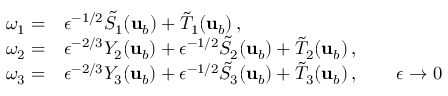<formula> <loc_0><loc_0><loc_500><loc_500>\begin{array} { r l } { \omega _ { 1 } = } & { \epsilon ^ { - 1 / 2 } \tilde { S } _ { 1 } ( { u } _ { b } ) + \tilde { T } _ { 1 } ( { u } _ { b } ) \, , } \\ { \omega _ { 2 } = } & { \epsilon ^ { - 2 / 3 } Y _ { 2 } ( { u } _ { b } ) + \epsilon ^ { - 1 / 2 } \tilde { S } _ { 2 } ( { u } _ { b } ) + \tilde { T } _ { 2 } ( { u } _ { b } ) \, , } \\ { \omega _ { 3 } = } & { \epsilon ^ { - 2 / 3 } Y _ { 3 } ( { u } _ { b } ) + \epsilon ^ { - 1 / 2 } \tilde { S } _ { 3 } ( { u } _ { b } ) + \tilde { T } _ { 3 } ( { u } _ { b } ) \, , \quad \epsilon \to 0 } \end{array}</formula> 